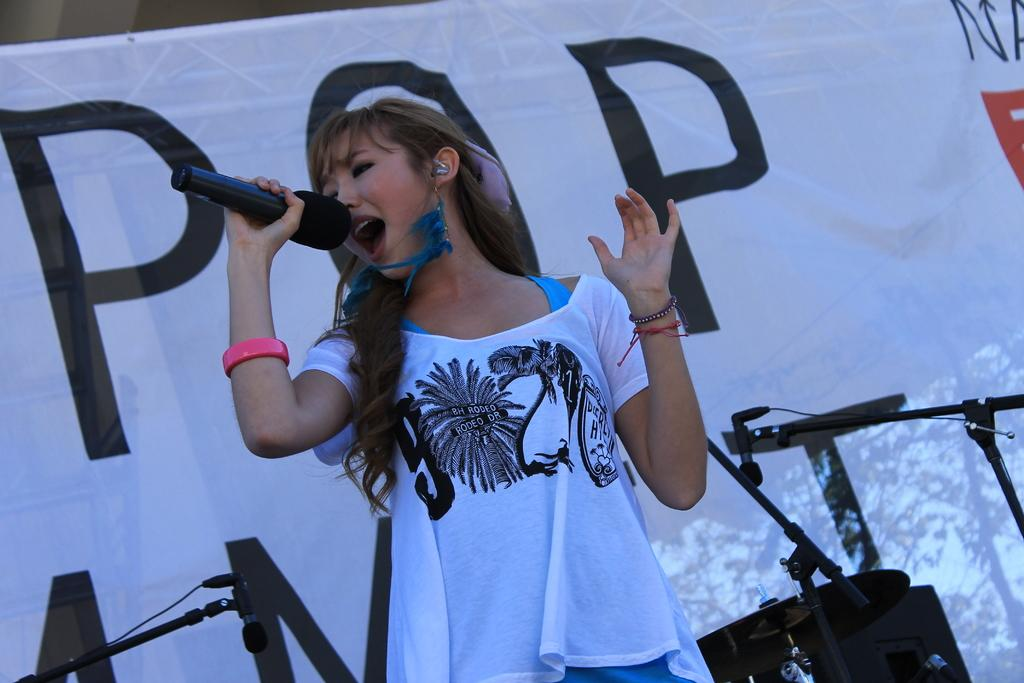Who is the main subject in the image? There is a woman in the image. What is the woman holding in the image? The woman is holding a microphone. What is the woman doing in the image? The woman is singing. What can be seen near the woman in the image? There are speakers near the woman. What is the banner in the image used for? The banner in the image has words on it, which suggests it might be used for displaying information or promoting something. Can you see a toothbrush being used by the woman in the image? There is no toothbrush present in the image. Is there a ghost visible in the image? There is no ghost present in the image. 